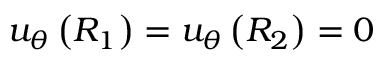Convert formula to latex. <formula><loc_0><loc_0><loc_500><loc_500>u _ { \theta } \left ( R _ { 1 } \right ) = u _ { \theta } \left ( R _ { 2 } \right ) = 0</formula> 